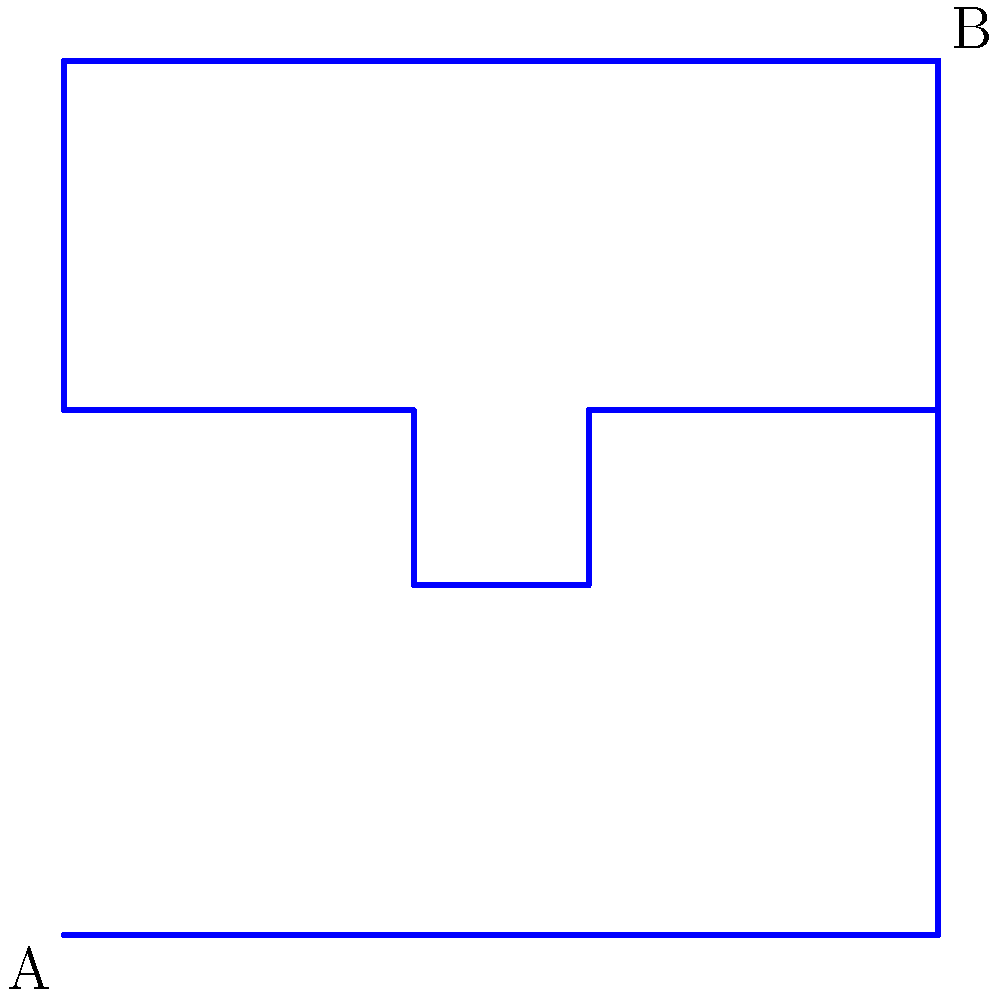In the postmodern novel "Echoes of Infinity," the protagonist encounters a labyrinth diagram similar to the one shown above. What could the central point C symbolize in relation to the character's journey from point A to point B? To analyze the symbolic meaning of this labyrinth diagram, let's consider the following steps:

1. Recognize the overall structure: The diagram shows a path from point A to point B, with a complex route that passes through the center point C.

2. Interpret the starting point A: This likely represents the beginning of the protagonist's journey or their initial state of being.

3. Analyze the endpoint B: This could symbolize the character's goal or final destination in their personal or literal journey.

4. Examine the path: The winding route between A and B suggests obstacles, challenges, or periods of confusion the character must navigate.

5. Focus on the central point C: This point is crucial as all paths seem to converge here before reaching the final destination.

6. Consider the significance of C:
   a) It could represent a moment of clarity or self-realization.
   b) It might symbolize a pivotal decision or turning point in the story.
   c) It could indicate a central truth or revelation the character must confront.

7. Relate to postmodern themes: The complex, non-linear path reflects postmodern ideas about the nature of truth, reality, and personal growth.

8. Connect to the character's journey: The central point likely represents a crucial moment of transformation or understanding that is necessary for the protagonist to reach their goal.

Given the postmodern context and the labyrinthine nature of the diagram, the most likely interpretation is that point C symbolizes a moment of profound self-realization or confrontation with a central truth, which is essential for the character's growth and progression towards their ultimate goal.
Answer: A moment of profound self-realization or confrontation with a central truth 